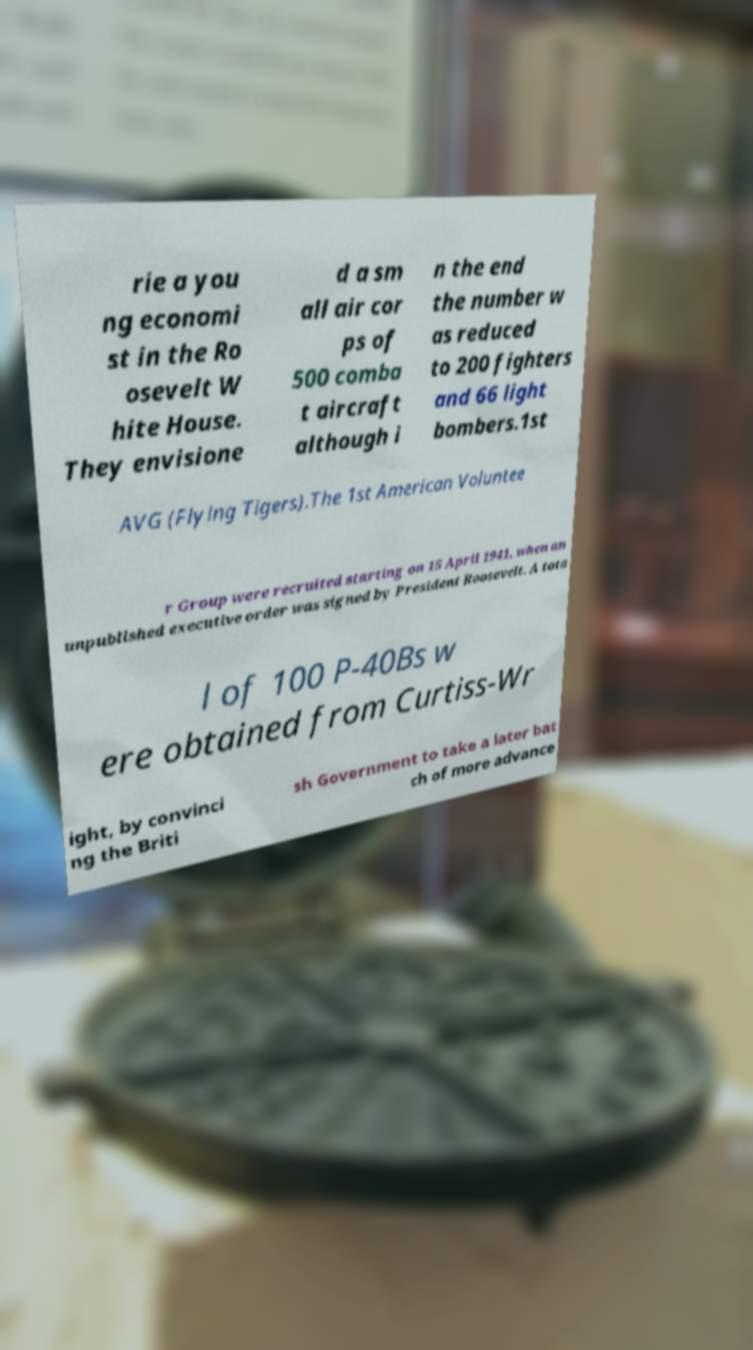I need the written content from this picture converted into text. Can you do that? rie a you ng economi st in the Ro osevelt W hite House. They envisione d a sm all air cor ps of 500 comba t aircraft although i n the end the number w as reduced to 200 fighters and 66 light bombers.1st AVG (Flying Tigers).The 1st American Voluntee r Group were recruited starting on 15 April 1941, when an unpublished executive order was signed by President Roosevelt. A tota l of 100 P-40Bs w ere obtained from Curtiss-Wr ight, by convinci ng the Briti sh Government to take a later bat ch of more advance 